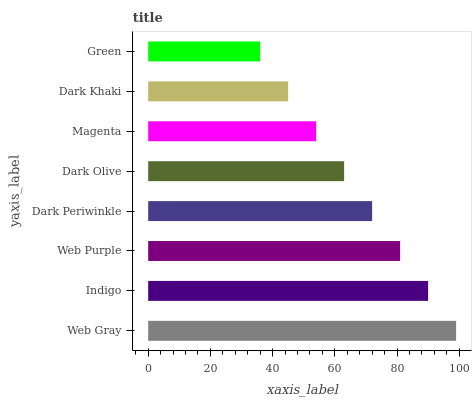Is Green the minimum?
Answer yes or no. Yes. Is Web Gray the maximum?
Answer yes or no. Yes. Is Indigo the minimum?
Answer yes or no. No. Is Indigo the maximum?
Answer yes or no. No. Is Web Gray greater than Indigo?
Answer yes or no. Yes. Is Indigo less than Web Gray?
Answer yes or no. Yes. Is Indigo greater than Web Gray?
Answer yes or no. No. Is Web Gray less than Indigo?
Answer yes or no. No. Is Dark Periwinkle the high median?
Answer yes or no. Yes. Is Dark Olive the low median?
Answer yes or no. Yes. Is Dark Khaki the high median?
Answer yes or no. No. Is Magenta the low median?
Answer yes or no. No. 